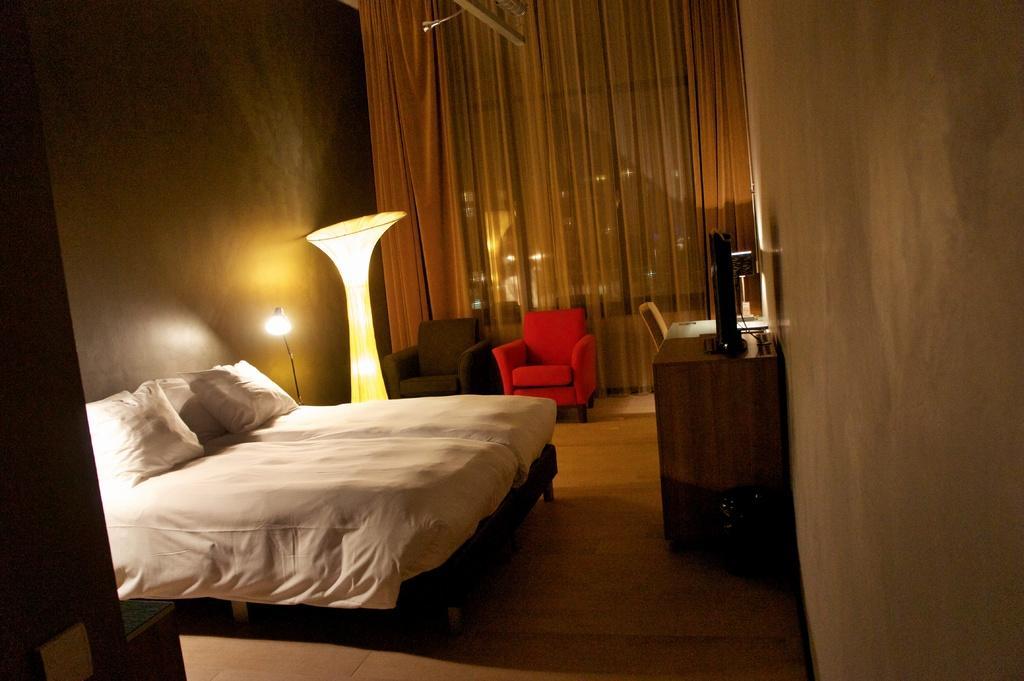Describe this image in one or two sentences. There are pillows on a bed, lamps, sofas and other objects on the desk in the foreground area of the image, there are curtains in the background. 